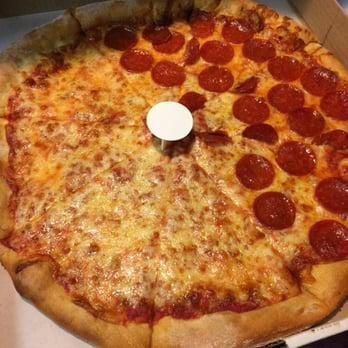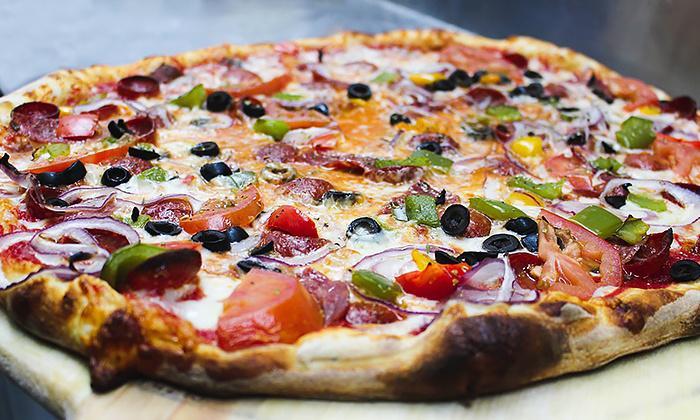The first image is the image on the left, the second image is the image on the right. Examine the images to the left and right. Is the description "In at least one image one slice of pizza has been separated from the rest of the pizza." accurate? Answer yes or no. No. The first image is the image on the left, the second image is the image on the right. Analyze the images presented: Is the assertion "There are two whole pizzas." valid? Answer yes or no. Yes. 